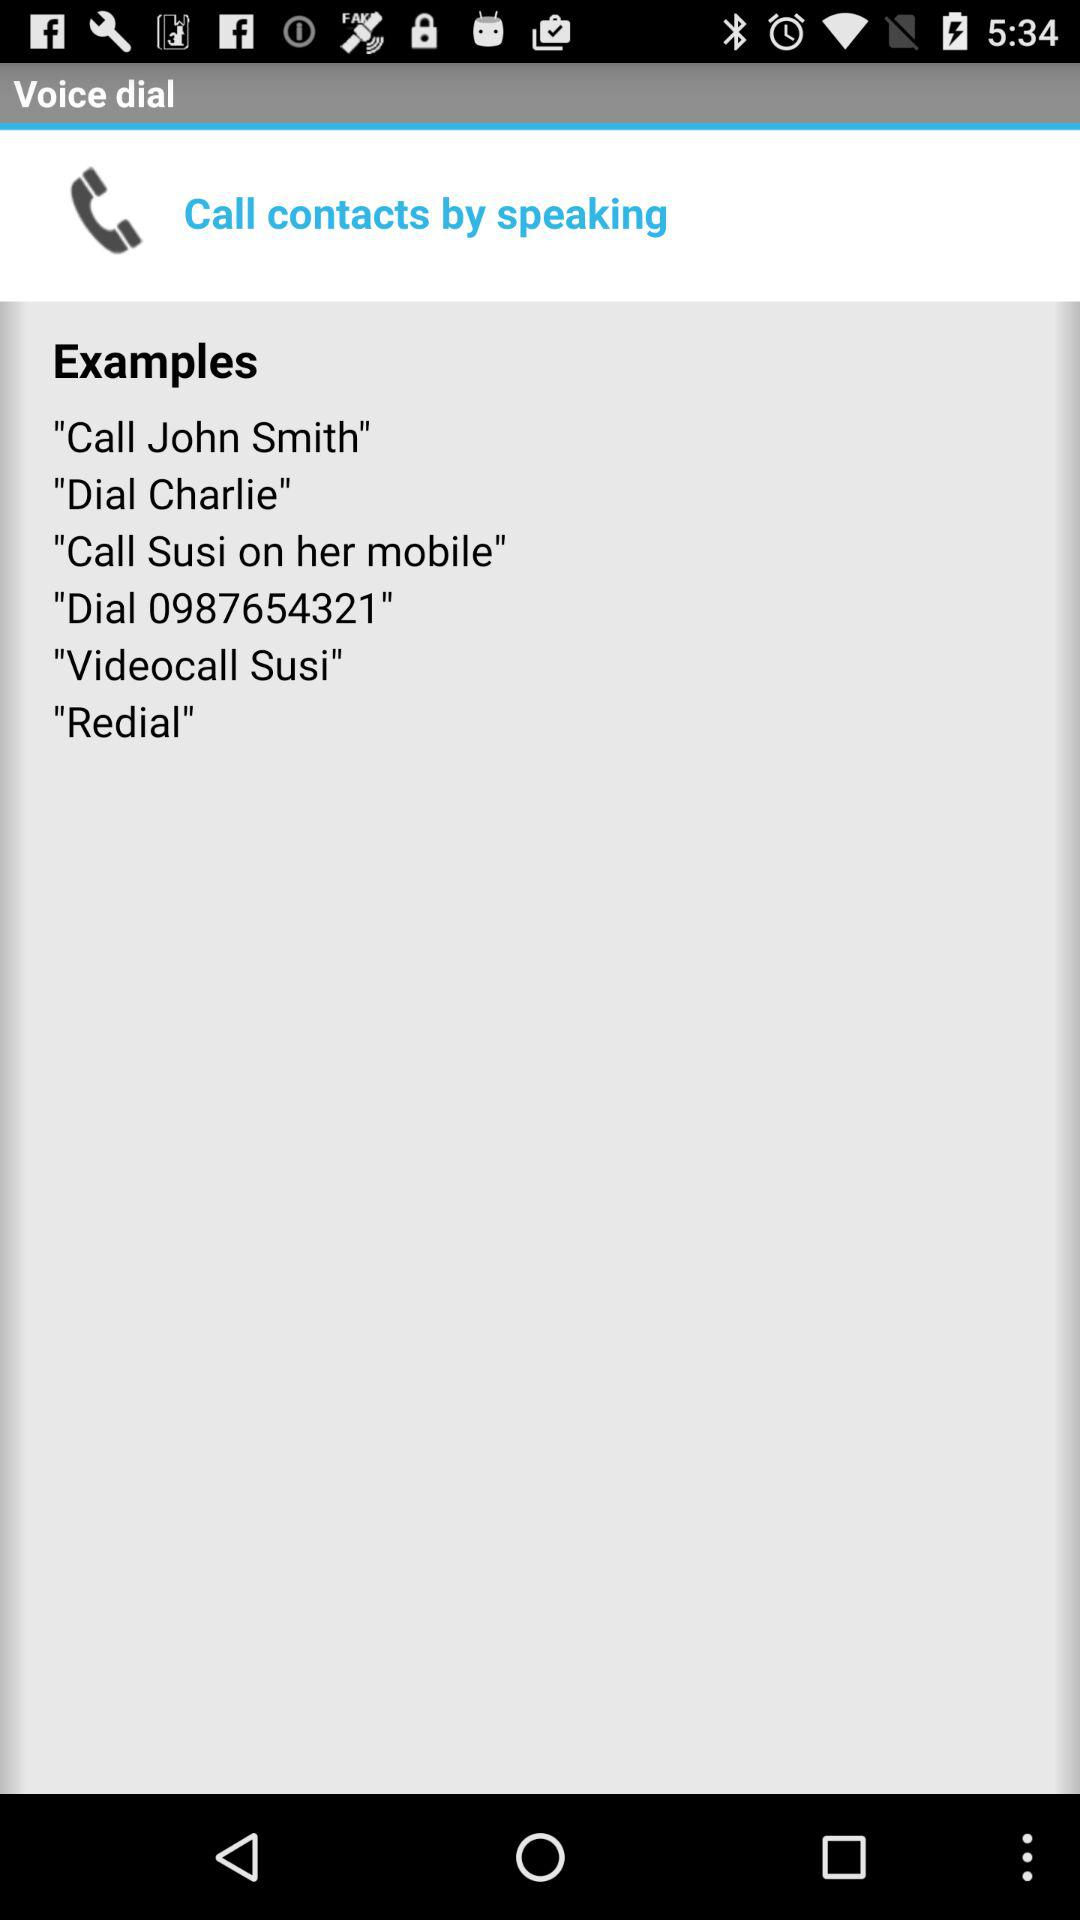What is the dial number? The dial number is 0987654321. 